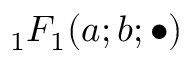Convert formula to latex. <formula><loc_0><loc_0><loc_500><loc_500>{ _ { 1 } F _ { 1 } } ( a ; b ; \bullet )</formula> 